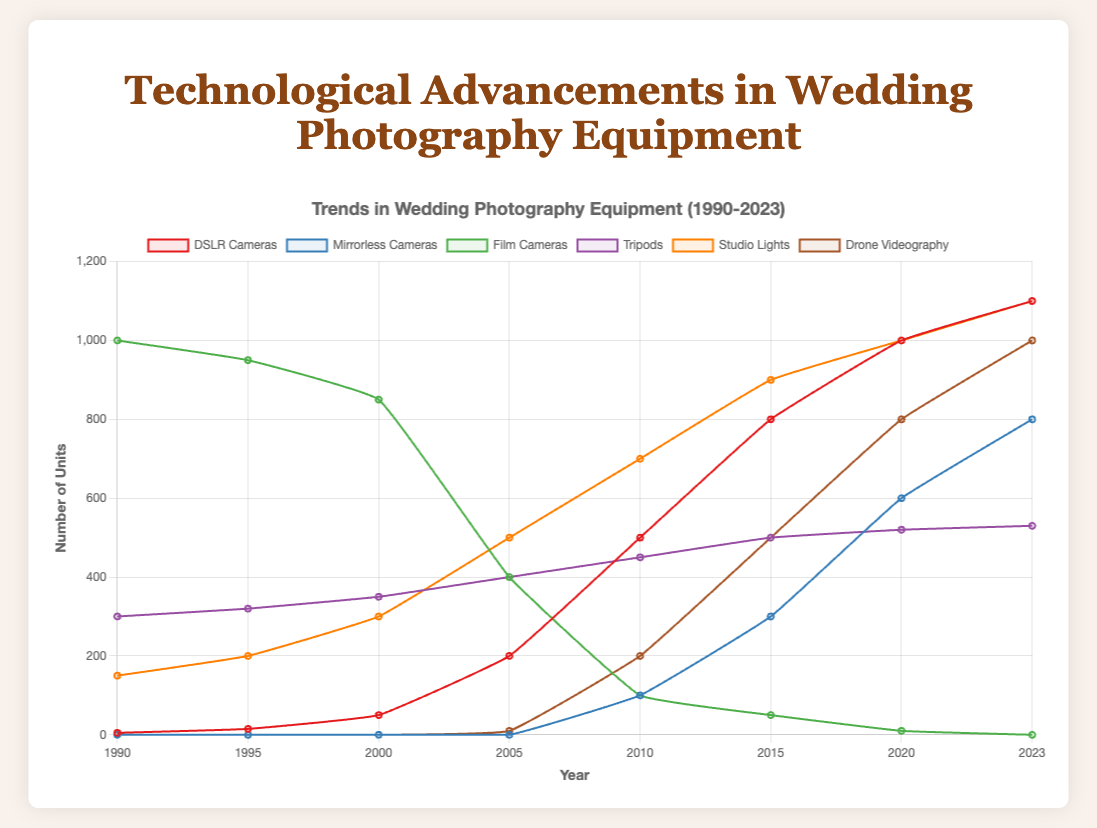What is the trend of Film Cameras from 1990 to 2023? The trend for Film Cameras shows a continuous decline from 1000 units in 1990 down to 0 units by 2023.
Answer: Continuous decline Which equipment saw the most significant increase between 2005 and 2023? By comparing the increase in units for each equipment type from 2005 to 2023, we see that DSLR Cameras increased from 200 to 1100 units whereas Drone Videography increased from 10 to 1000 units, making Drone Videography the equipment with the most significant increase.
Answer: Drone Videography How do the numbers of DSMR Cameras and Mirrorless Cameras compare in 2010? In 2010, the number of DSLR Cameras is 500 units, and Mirrorless Cameras is 100 units. So, DSLR Cameras have higher numbers than Mirrorless Cameras in 2010.
Answer: DSLR Cameras have higher numbers What is the combined total of Studio Lights and Tripods for the year 2015? In 2015, Studio Lights is 900 units, and Tripods is 500 units. The combined total is 900 + 500 = 1400 units.
Answer: 1400 units Which equipment had no presence before 2010? Review the presence of equipment over the years, and we find that both Mirrorless Cameras and Drone Videography had no units before 2010.
Answer: Mirrorless Cameras and Drone Videography What is the difference in the number of Mirrorless Cameras between 2015 and 2020? In 2015, Mirrorless Cameras is 300 units, and in 2020, it is 600 units. The difference is 600 - 300 = 300 units.
Answer: 300 units Compare the trends of Studio Lights and Tripods from 1990 to 2023. Studio Lights show a steady increase from 150 units in 1990 to 1100 units in 2023, while Tripods have a gradual increase from 300 units in 1990 to 530 units in 2023. Both exhibit growth, but Studio Lights increase at a faster rate.
Answer: Studio Lights increase at a faster rate Is there any year where the number of Film Cameras and DSLRs are equal? By reviewing each year’s data for Film Cameras and DSLRs, we find that there is no year where their numbers are equal.
Answer: No How did the introduction and rise of Mirrorless Cameras impact Film Cameras between 2010 and 2023? After Mirrorless Cameras were introduced in 2010 with 100 units and rose significantly to 800 units by 2023, Film Cameras dropped from 100 units in 2010 to 0 units by 2023. The rise of Mirrorless Cameras correlates with the decline of Film Cameras.
Answer: Decline of Film Cameras 